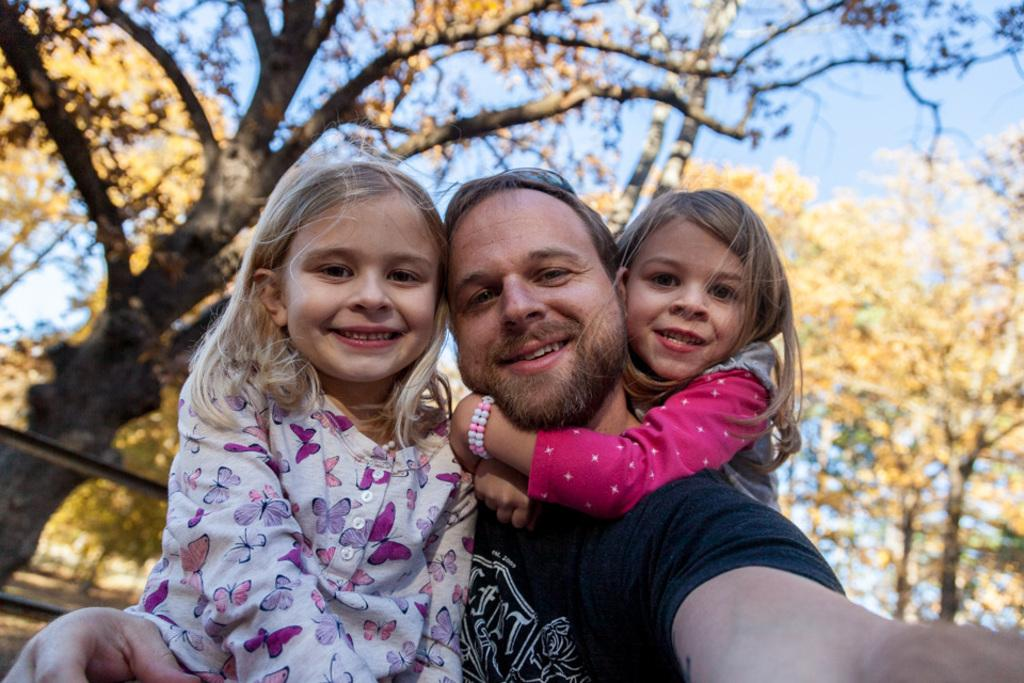How many people are present in the image? There are men and two kids in the image, making a total of four people. What are the kids and men doing in the image? The kids and men are taking a selfie. What can be seen in the background of the image? There are trees in the background of the image. What direction is the giraffe facing in the image? There is no giraffe present in the image. What event is taking place in the image? The image does not depict a specific event; it simply shows a group of people taking a selfie. 